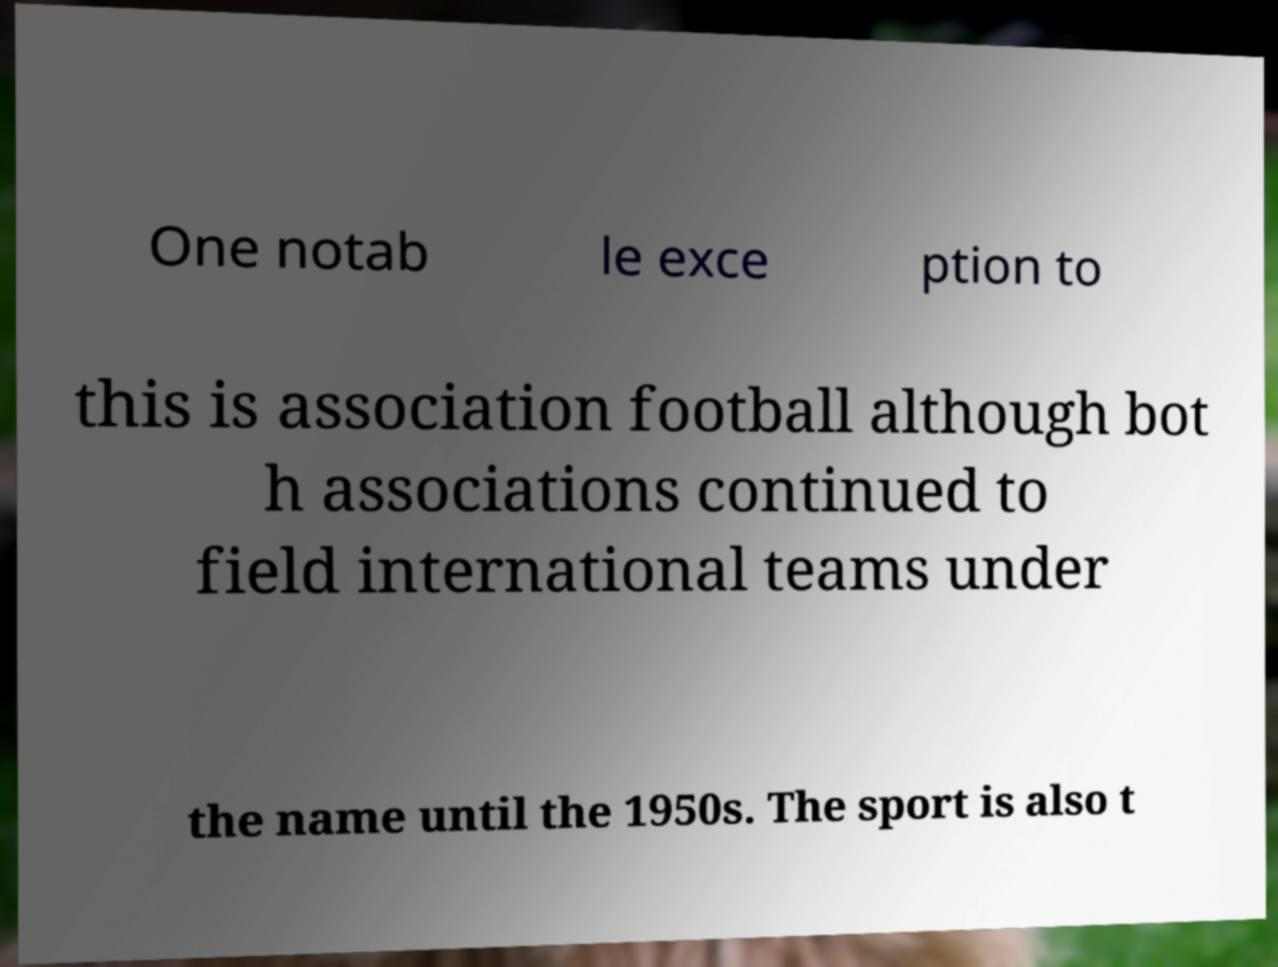For documentation purposes, I need the text within this image transcribed. Could you provide that? One notab le exce ption to this is association football although bot h associations continued to field international teams under the name until the 1950s. The sport is also t 